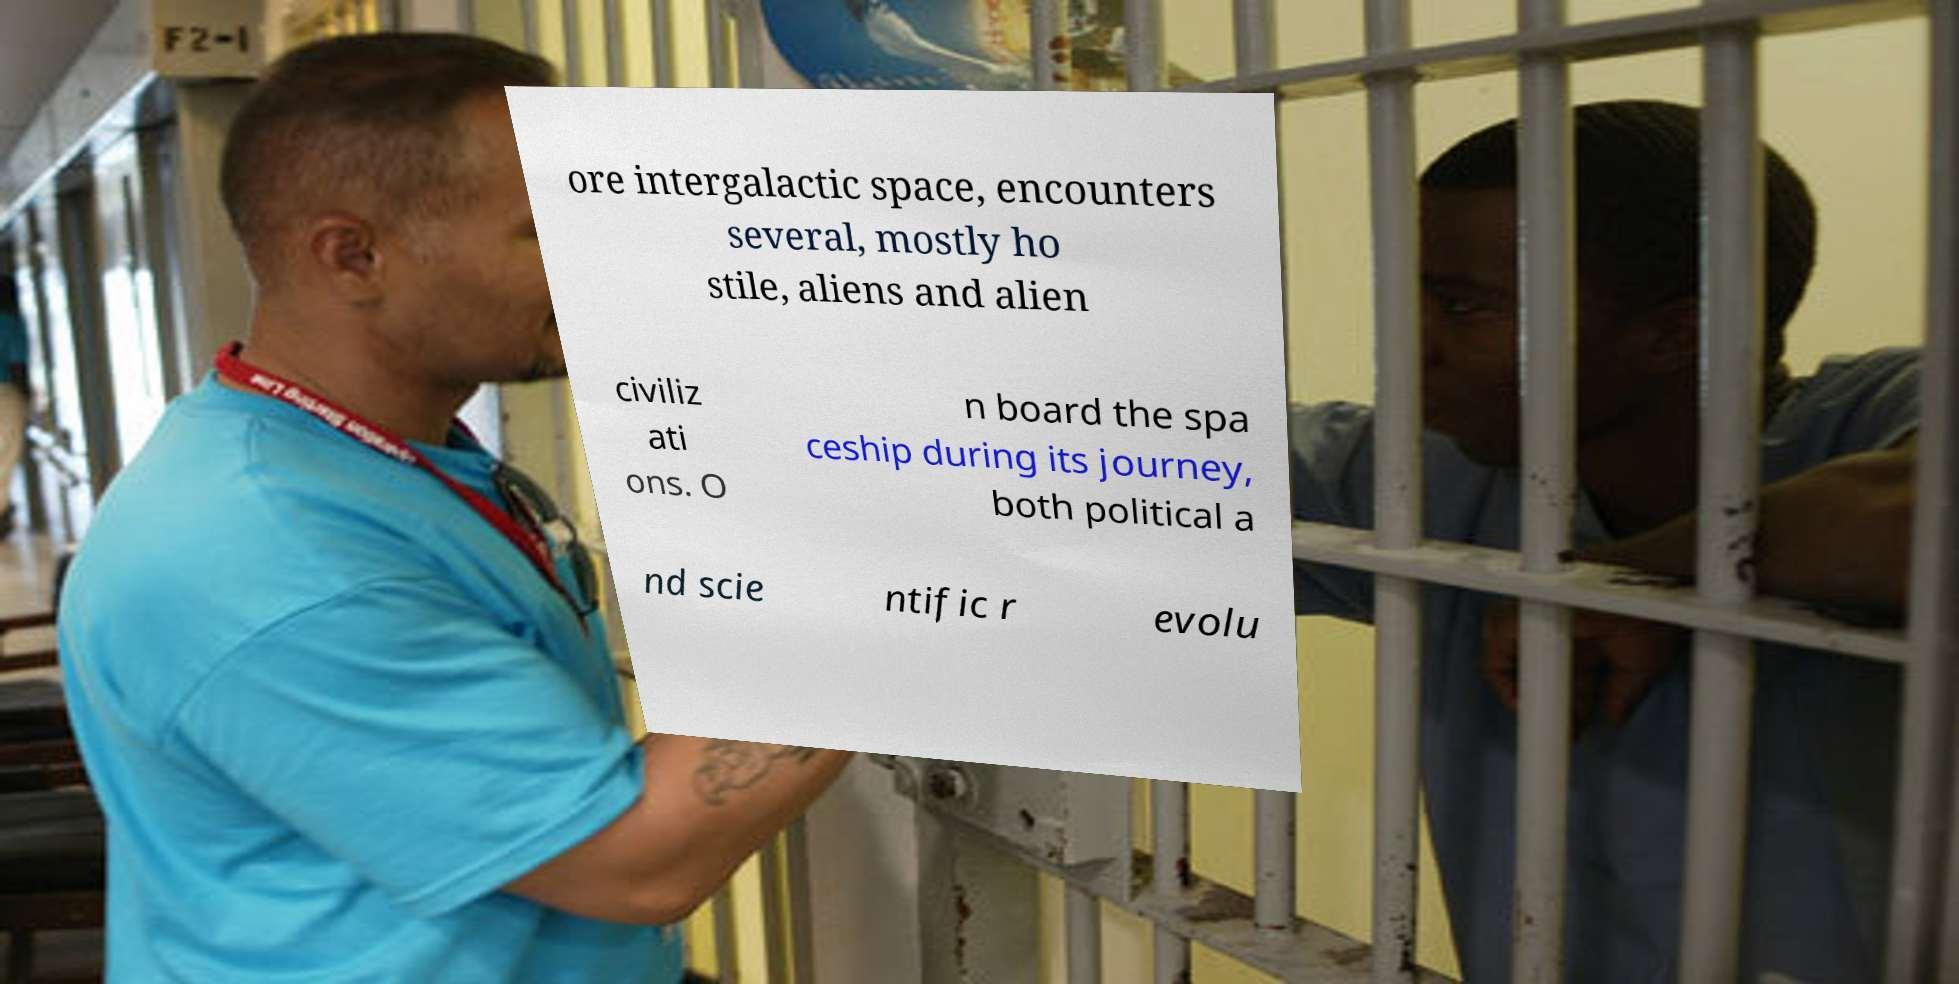Please identify and transcribe the text found in this image. ore intergalactic space, encounters several, mostly ho stile, aliens and alien civiliz ati ons. O n board the spa ceship during its journey, both political a nd scie ntific r evolu 